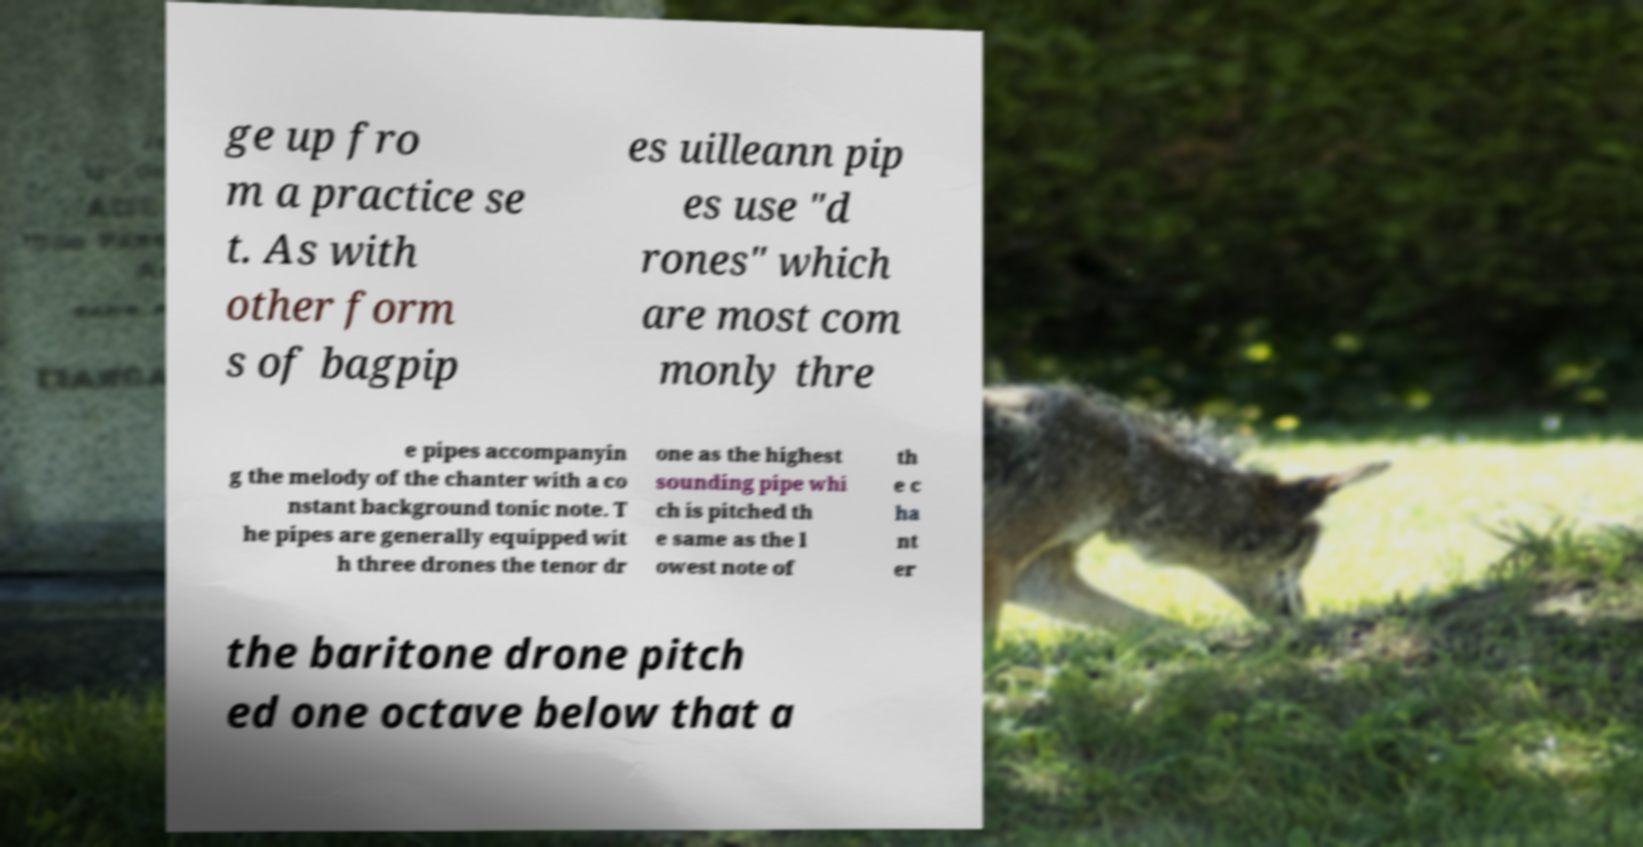I need the written content from this picture converted into text. Can you do that? ge up fro m a practice se t. As with other form s of bagpip es uilleann pip es use "d rones" which are most com monly thre e pipes accompanyin g the melody of the chanter with a co nstant background tonic note. T he pipes are generally equipped wit h three drones the tenor dr one as the highest sounding pipe whi ch is pitched th e same as the l owest note of th e c ha nt er the baritone drone pitch ed one octave below that a 